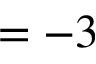<formula> <loc_0><loc_0><loc_500><loc_500>= - 3</formula> 